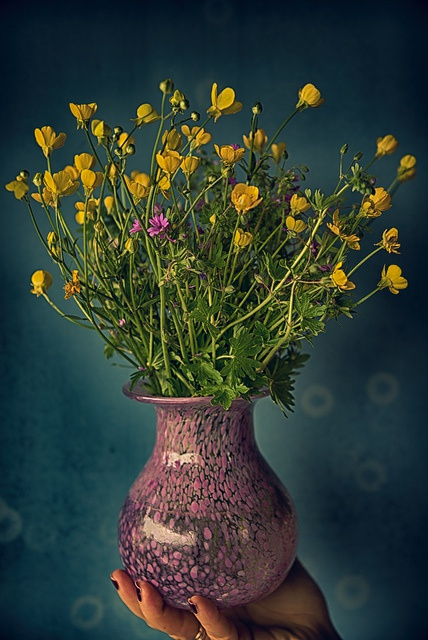Describe the objects in this image and their specific colors. I can see potted plant in black, darkgreen, and teal tones, vase in black and brown tones, and people in black, maroon, brown, and red tones in this image. 